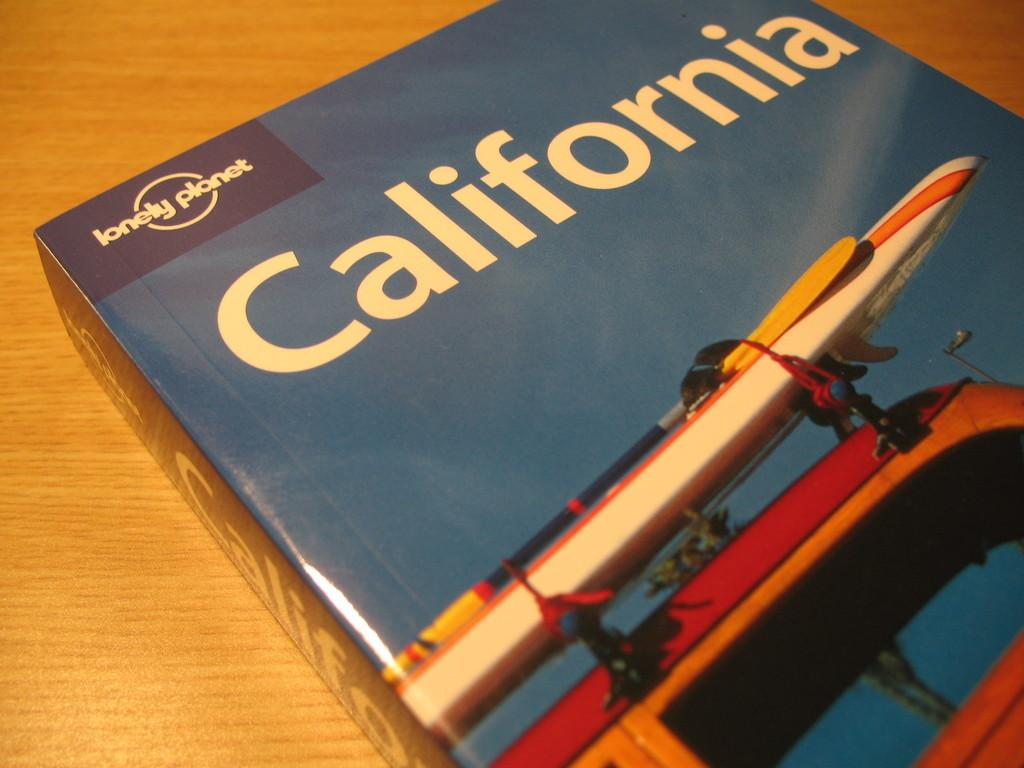<image>
Summarize the visual content of the image. A box with California printed on the top shows a picture of a kayak on top of a car. 